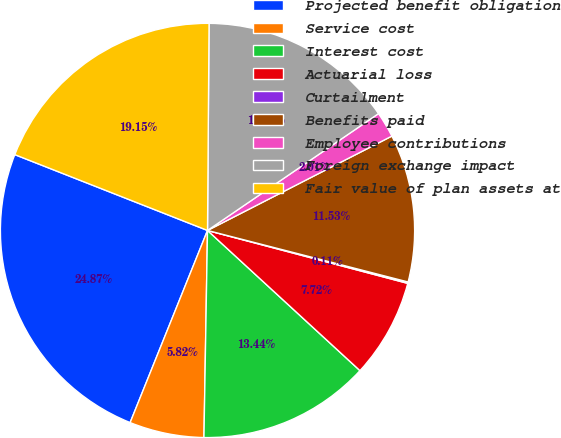Convert chart. <chart><loc_0><loc_0><loc_500><loc_500><pie_chart><fcel>Projected benefit obligation<fcel>Service cost<fcel>Interest cost<fcel>Actuarial loss<fcel>Curtailment<fcel>Benefits paid<fcel>Employee contributions<fcel>Foreign exchange impact<fcel>Fair value of plan assets at<nl><fcel>24.87%<fcel>5.82%<fcel>13.44%<fcel>7.72%<fcel>0.11%<fcel>11.53%<fcel>2.01%<fcel>15.34%<fcel>19.15%<nl></chart> 